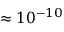<formula> <loc_0><loc_0><loc_500><loc_500>\approx 1 0 ^ { - 1 0 }</formula> 